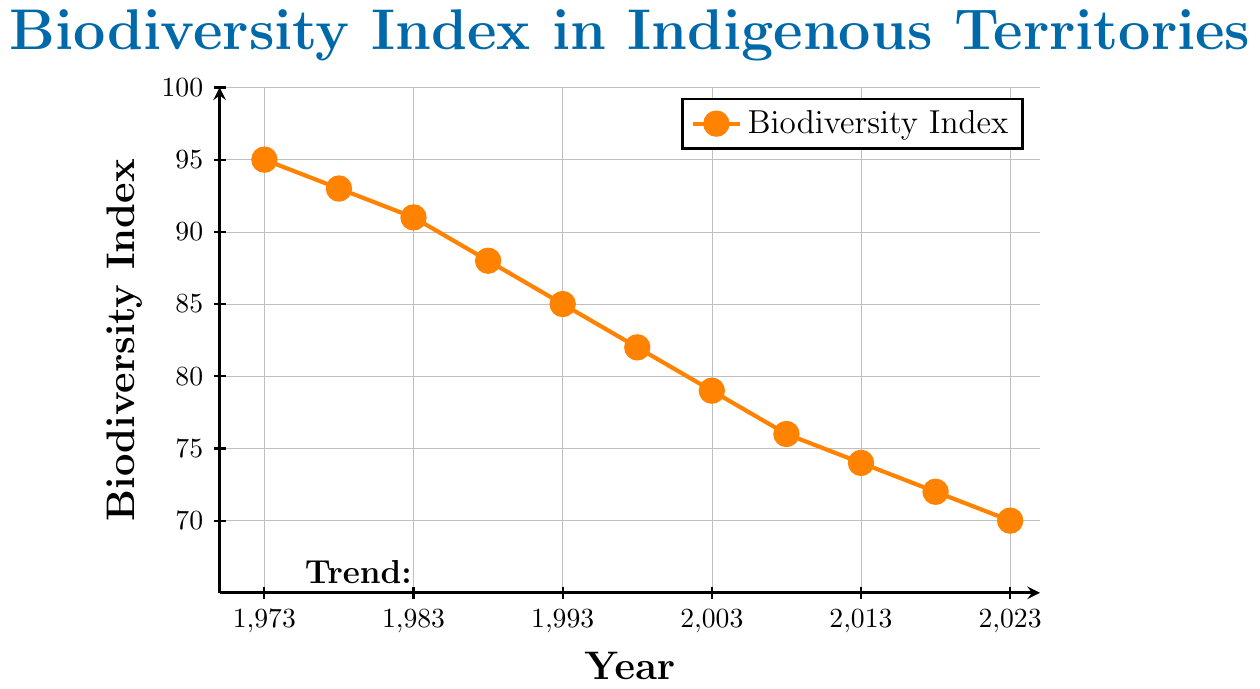What was the Biodiversity Index in 1983? By looking at the plot, locate the year 1983 on the x-axis and follow it up to the corresponding point on the line, which aligns with the y-axis value of 91.
Answer: 91 How much did the Biodiversity Index decrease from 1973 to 2023? First, find the Biodiversity Index for 1973, which is 95. Then, locate the Biodiversity Index for 2023, which is 70. Subtract 70 from 95 to find the decrease.
Answer: 25 Between which consecutive years did the Biodiversity Index have the sharpest decline? To find this, compare the decrease in the Biodiversity Index between each set of consecutive years: 1973-1978 (2), 1978-1983 (2), 1983-1988 (3), 1988-1993 (3), 1993-1998 (3), 1998-2003 (3), 2003-2008 (3), 2008-2013 (2), 2013-2018 (2), 2018-2023 (2). The largest decline (3) happened between multiple sets of consecutive years (1983-1988, 1988-1993, 1993-1998, 1998-2003, 2003-2008).
Answer: 1983-1988, 1988-1993, 1993-1998, 1998-2003, 2003-2008 What is the average decrease in Biodiversity Index per decade from 1973 to 2023? To find the average decrease per decade, first calculate the total decrease from 1973 (95) to 2023 (70), which is 25. There are 5 decades over this period (2023-1973)/10 = 5. Divide the total decrease by the number of decades: 25 / 5.
Answer: 5 In which year was the Biodiversity Index 76? Locate the point on the y-axis corresponding to 76, and then follow the horizontal grid line to intersect with the plot's line. The corresponding year on the x-axis is 2008.
Answer: 2008 By how much did the Biodiversity Index change between 1993 and 2013? Find the Biodiversity Index for 1993 (85) and for 2013 (74). Subtract the latter from the former to find the change: 85 - 74.
Answer: 11 What overall trend does the graph indicate about the Biodiversity Index over the last 50 years? The graph shows a downward trend from 1973 to 2023, indicating a steady decline in the Biodiversity Index over this period.
Answer: Steady decline Which decade experienced the smallest decrease in Biodiversity Index? By calculating the decrease in the Biodiversity Index for each decade: 1973-1983 (95-91=4), 1983-1993 (91-85=6), 1993-2003 (85-79=6), 2003-2013 (79-74=5), 2013-2023 (74-70=4). The smallest decrease (4) happened in two different decades, 1973-1983 and 2013-2023.
Answer: 1973-1983 and 2013-2023 